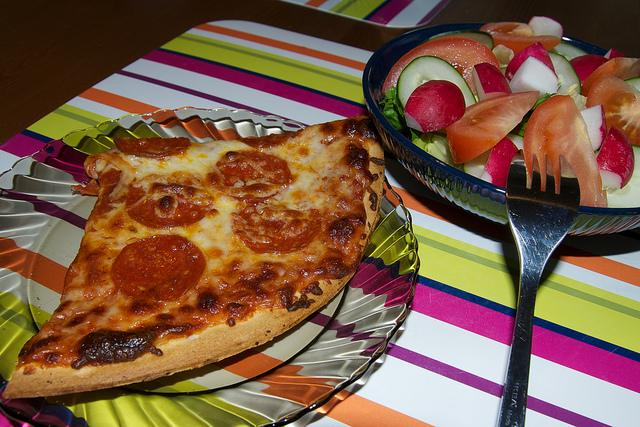What kind of side meal is there a serving of near the pizza?

Choices:
A) parsley
B) potato chips
C) salad
D) french fries salad 